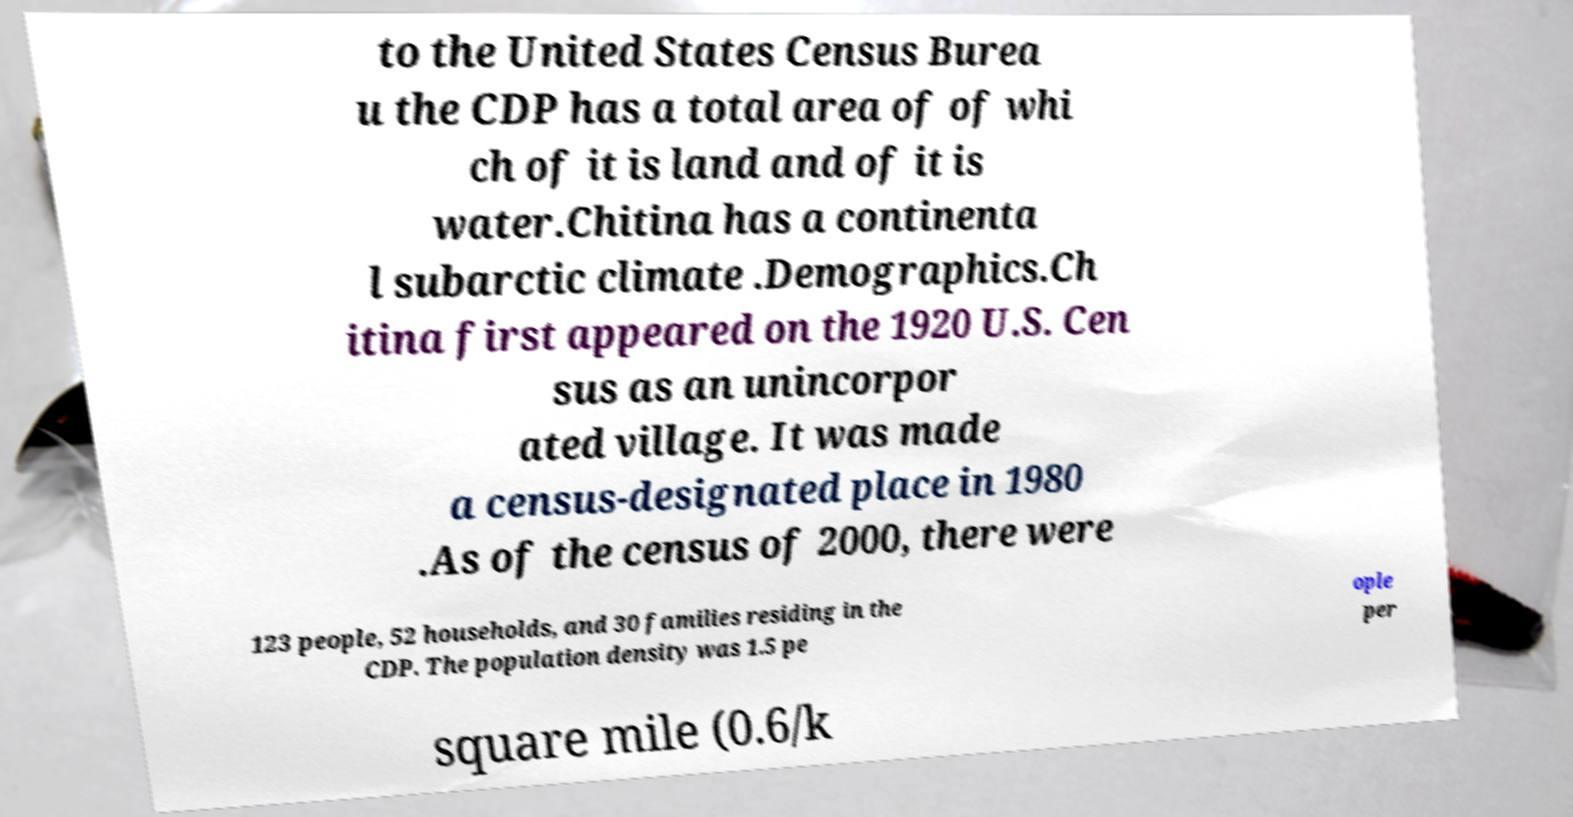Could you assist in decoding the text presented in this image and type it out clearly? to the United States Census Burea u the CDP has a total area of of whi ch of it is land and of it is water.Chitina has a continenta l subarctic climate .Demographics.Ch itina first appeared on the 1920 U.S. Cen sus as an unincorpor ated village. It was made a census-designated place in 1980 .As of the census of 2000, there were 123 people, 52 households, and 30 families residing in the CDP. The population density was 1.5 pe ople per square mile (0.6/k 